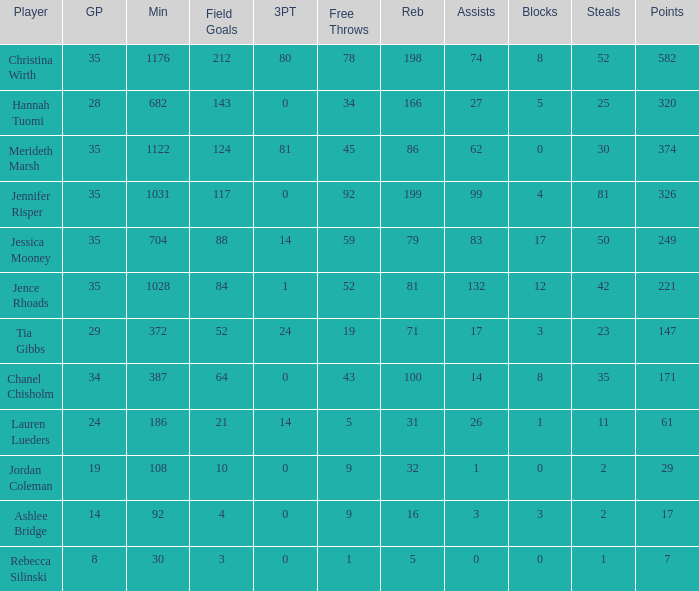How much time, in minutes, did Chanel Chisholm play? 1.0. 